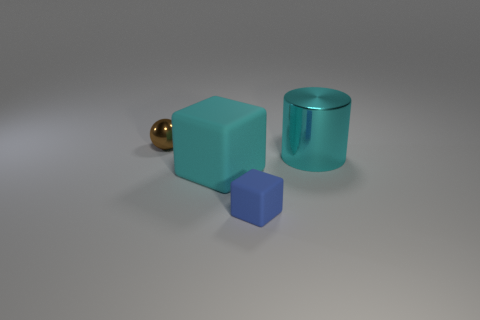There is a large cube that is the same color as the cylinder; what material is it?
Your answer should be very brief. Rubber. Is there a tiny brown sphere in front of the small object in front of the tiny metal object?
Provide a succinct answer. No. The shiny object that is in front of the brown metallic thing has what shape?
Provide a short and direct response. Cylinder. There is a small object behind the object right of the blue matte cube; what number of brown shiny balls are to the right of it?
Offer a terse response. 0. Does the blue rubber object have the same size as the shiny thing to the left of the big cyan matte block?
Your answer should be very brief. Yes. What size is the cyan metal cylinder behind the big object on the left side of the large metal cylinder?
Your answer should be very brief. Large. What number of cyan cubes have the same material as the big cylinder?
Provide a short and direct response. 0. Are there any big green shiny cylinders?
Your answer should be compact. No. There is a metal thing that is to the left of the small blue object; how big is it?
Provide a succinct answer. Small. How many other big objects have the same color as the large matte thing?
Give a very brief answer. 1. 